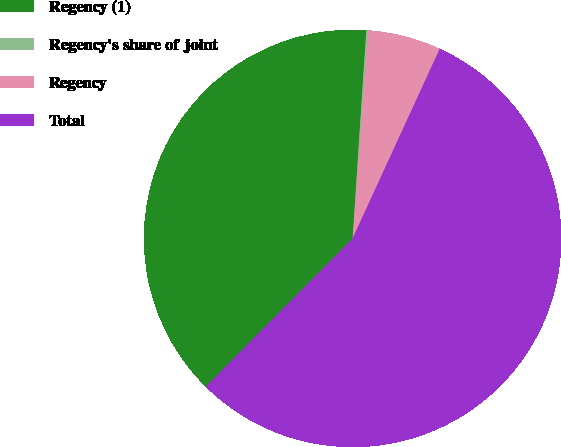<chart> <loc_0><loc_0><loc_500><loc_500><pie_chart><fcel>Regency (1)<fcel>Regency's share of joint<fcel>Regency<fcel>Total<nl><fcel>38.61%<fcel>0.13%<fcel>5.68%<fcel>55.58%<nl></chart> 